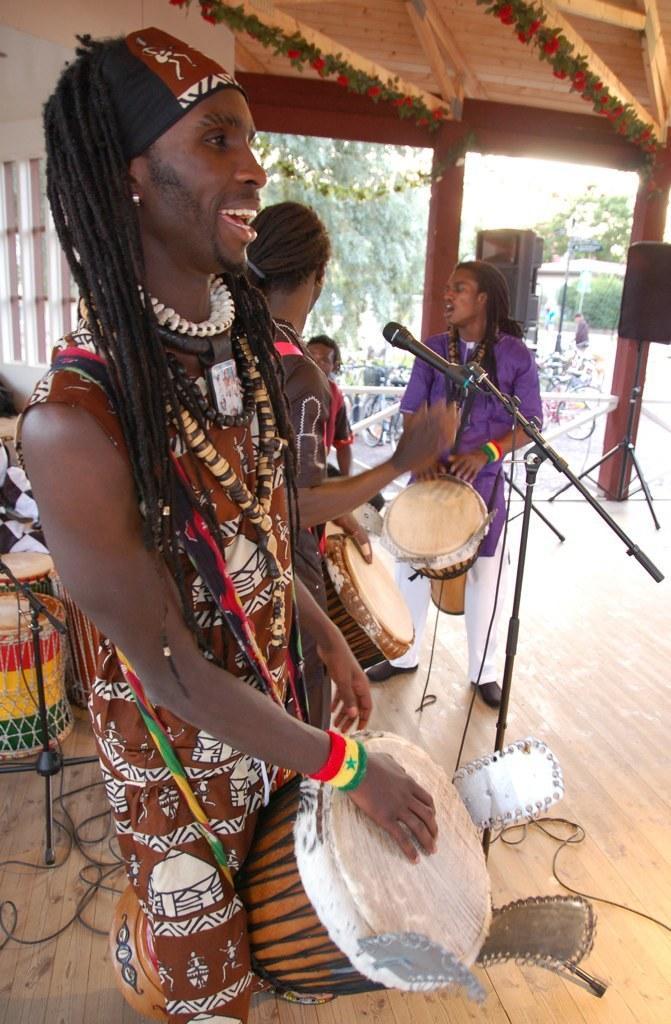How would you summarize this image in a sentence or two? Front this person is playing this musical instrument. Far this two persons are also playing these musical drum. At background there are musical instruments. This shed is decorated with flowers. Far there are trees and plants. These are speakers with stand. They are bicycles. 